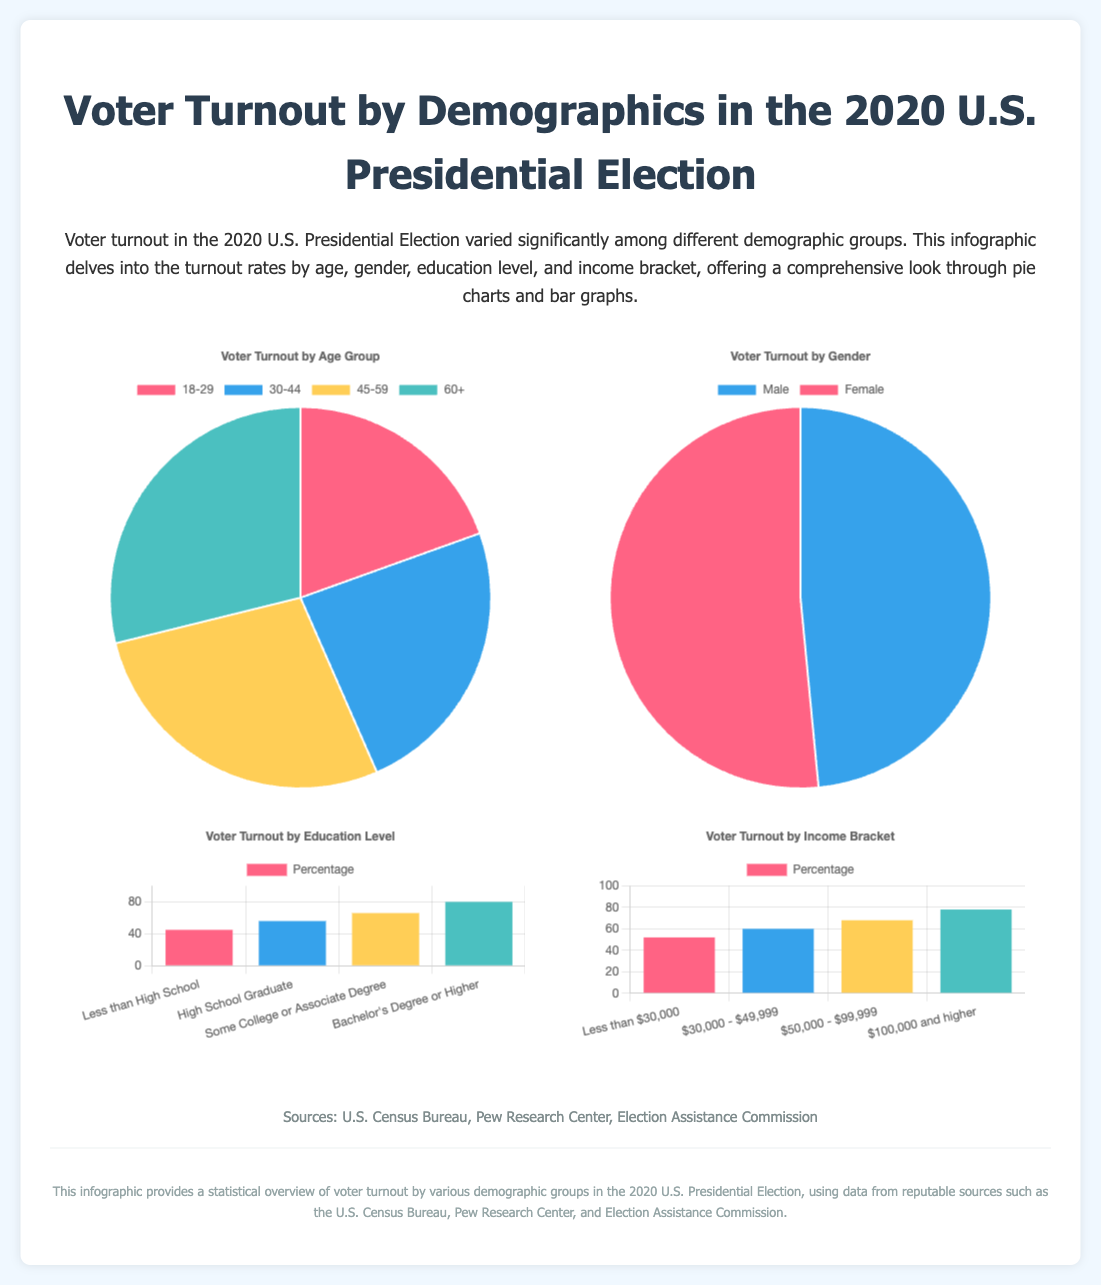what is the voter turnout percentage for the age group 18-29? The voter turnout percentage for the age group 18-29 is shown in the pie chart depicting age demographics.
Answer: 51.4 which gender had a higher voter turnout? The gender chart compares the turnout rates for males and females.
Answer: Female what is the voter turnout percentage for those with a Bachelor's Degree or Higher? The bar graph for education level displays turnout for various educational backgrounds.
Answer: 80.0 which income bracket had the lowest voter turnout percentage? The lowest percentage in the income bracket's bar graph indicates the turnout for that category.
Answer: Less than $30,000 how many age groups are represented in the infographic? The age portion of the document includes multiple categories with data.
Answer: Four what demographic had a voter turnout of 68.0 percent? This percentage is indicated for one of the categories in the gender chart.
Answer: Female which education level category had a percentage below 60%? The bar graph for education reveals the turnout percentages for each category.
Answer: Less than High School what is the total voter turnout percentage for the age group 60 and older? The pie chart on age demographics includes this specific group and its turnout.
Answer: 76.0 how many categories are used to display income brackets? The income chart illustrates various ranges for voter turnout.
Answer: Four 